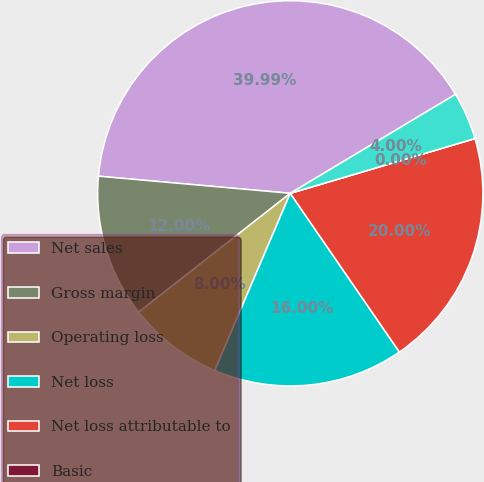Convert chart to OTSL. <chart><loc_0><loc_0><loc_500><loc_500><pie_chart><fcel>Net sales<fcel>Gross margin<fcel>Operating loss<fcel>Net loss<fcel>Net loss attributable to<fcel>Basic<fcel>Diluted<nl><fcel>39.99%<fcel>12.0%<fcel>8.0%<fcel>16.0%<fcel>20.0%<fcel>0.0%<fcel>4.0%<nl></chart> 